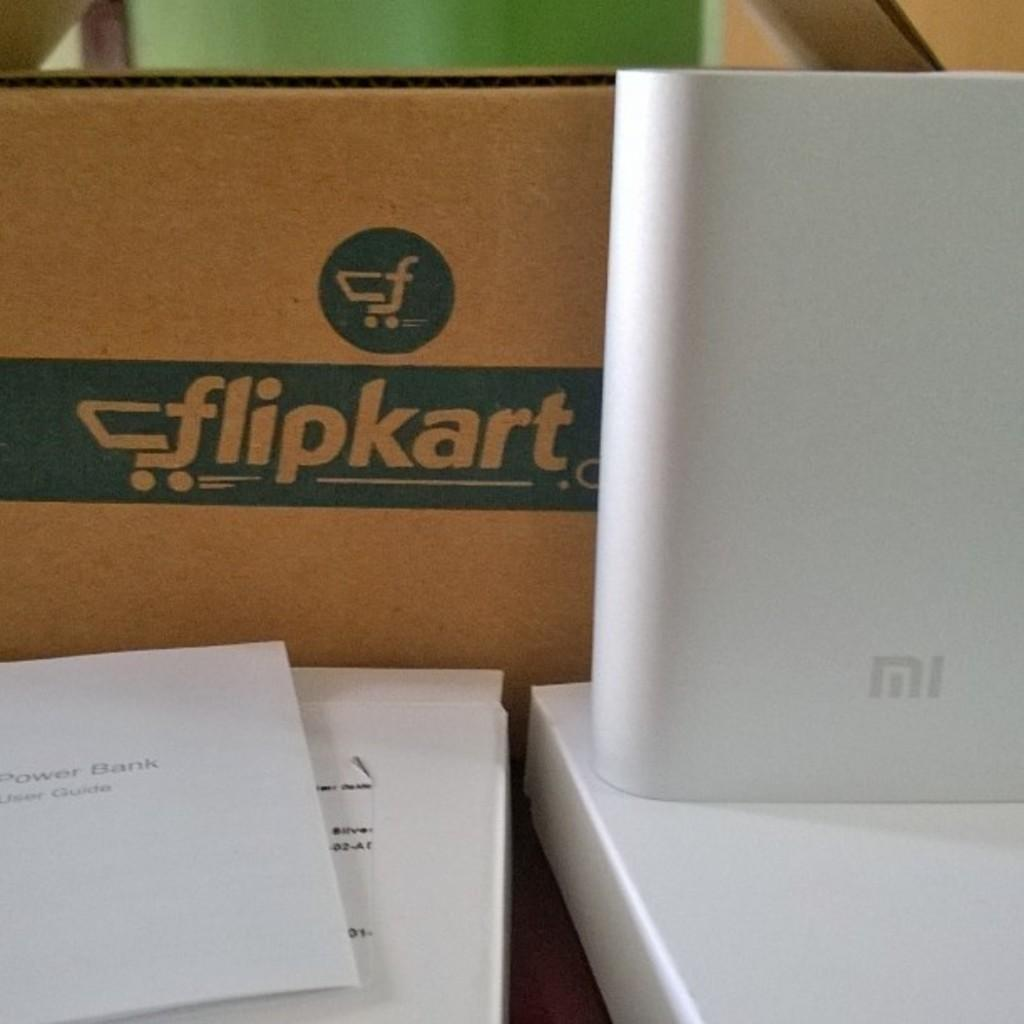<image>
Summarize the visual content of the image. A piece of paper in front of a box for flipkart. 